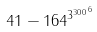<formula> <loc_0><loc_0><loc_500><loc_500>4 1 - 1 6 4 ^ { { 3 ^ { 3 0 0 } } ^ { 6 } }</formula> 